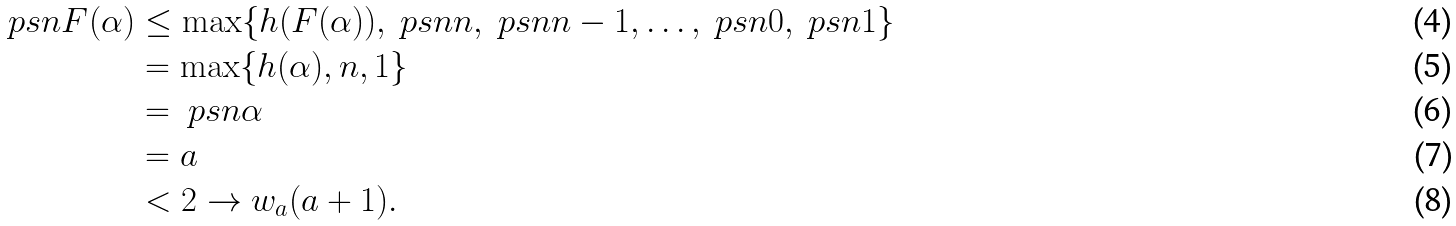<formula> <loc_0><loc_0><loc_500><loc_500>\ p s n { F ( \alpha ) } & \leq \max \{ h ( F ( \alpha ) ) , \ p s n { n } , \ p s n { n - 1 } , \dots , \ p s n { 0 } , \ p s n { 1 } \} \\ & = \max \{ h ( \alpha ) , n , 1 \} \\ & = \ p s n { \alpha } \\ & = a \\ & < 2 \to w _ { a } ( a + 1 ) .</formula> 